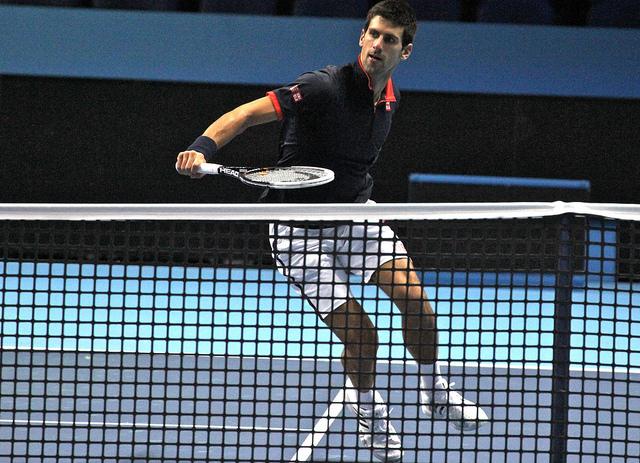Is the player underwater?
Write a very short answer. No. What is the player holding?
Be succinct. Tennis racket. Is the player jumping?
Short answer required. No. 